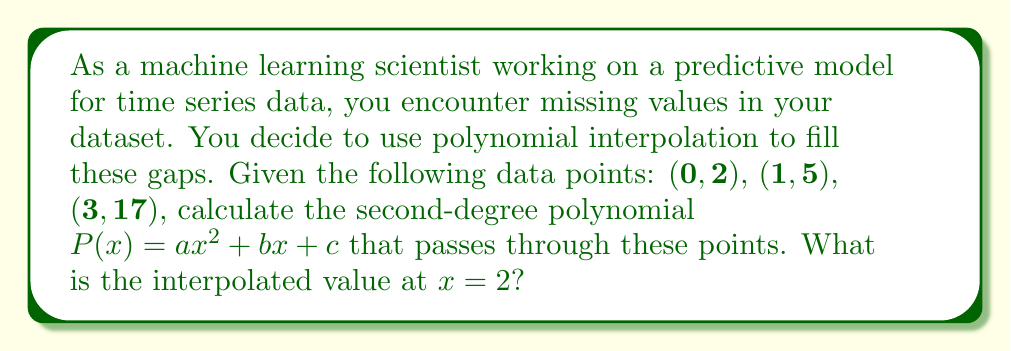Show me your answer to this math problem. To solve this problem, we'll follow these steps:

1) First, we need to find the coefficients $a$, $b$, and $c$ of the polynomial $P(x) = ax^2 + bx + c$ using the given points.

2) We can set up a system of equations:

   $$\begin{align}
   2 &= a(0)^2 + b(0) + c \\
   5 &= a(1)^2 + b(1) + c \\
   17 &= a(3)^2 + b(3) + c
   \end{align}$$

3) Simplifying:

   $$\begin{align}
   2 &= c \\
   5 &= a + b + 2 \\
   17 &= 9a + 3b + 2
   \end{align}$$

4) From the first equation, we know $c = 2$. Subtracting the second equation from the third:

   $$12 = 8a + 2b$$
   $$6 = 4a + b$$

5) Substituting this into the second equation:

   $$5 = a + (6 - 4a) + 2$$
   $$3 = -3a$$
   $$a = -1$$

6) Now we can find $b$:

   $$6 = 4(-1) + b$$
   $$b = 10$$

7) Therefore, our polynomial is:

   $$P(x) = -x^2 + 10x + 2$$

8) To find the interpolated value at $x = 2$, we simply substitute $x = 2$ into our polynomial:

   $$P(2) = -(2)^2 + 10(2) + 2$$
Answer: $P(2) = -4 + 20 + 2 = 18$ 